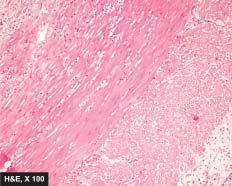what are necrosis of mucosa and periappendicitis?
Answer the question using a single word or phrase. Other changes present 